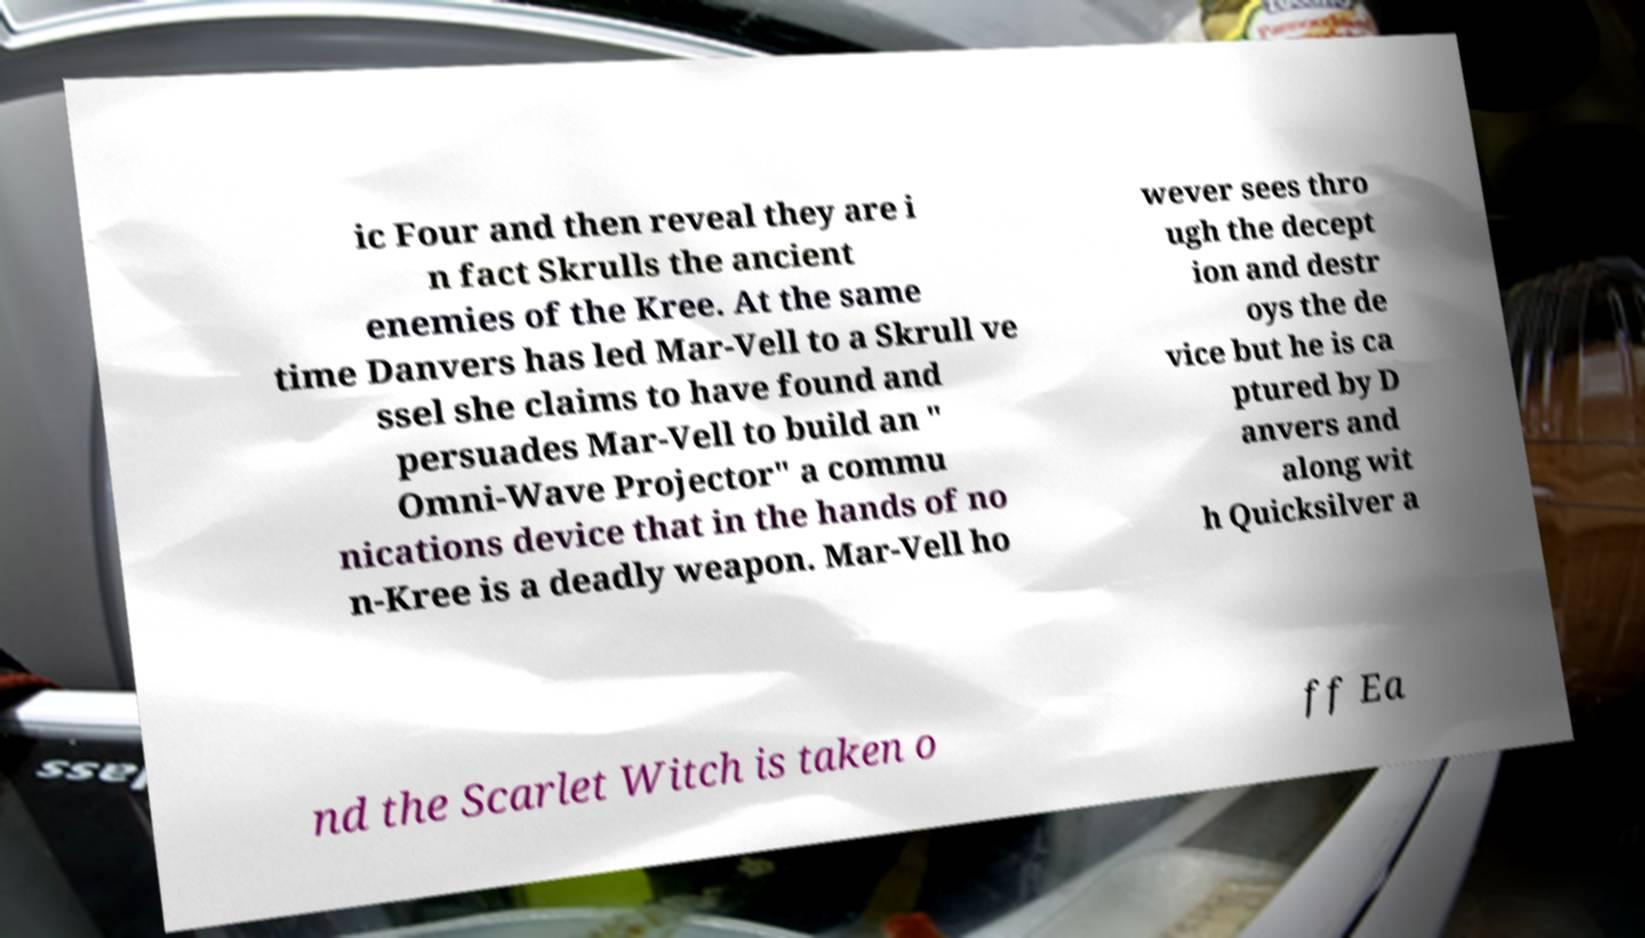Can you read and provide the text displayed in the image?This photo seems to have some interesting text. Can you extract and type it out for me? ic Four and then reveal they are i n fact Skrulls the ancient enemies of the Kree. At the same time Danvers has led Mar-Vell to a Skrull ve ssel she claims to have found and persuades Mar-Vell to build an " Omni-Wave Projector" a commu nications device that in the hands of no n-Kree is a deadly weapon. Mar-Vell ho wever sees thro ugh the decept ion and destr oys the de vice but he is ca ptured by D anvers and along wit h Quicksilver a nd the Scarlet Witch is taken o ff Ea 